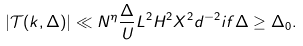<formula> <loc_0><loc_0><loc_500><loc_500>| \mathcal { T } ( k , \Delta ) | \ll N ^ { \eta } \frac { \Delta } { U } L ^ { 2 } H ^ { 2 } X ^ { 2 } d ^ { - 2 } i f \Delta \geq \Delta _ { 0 } .</formula> 